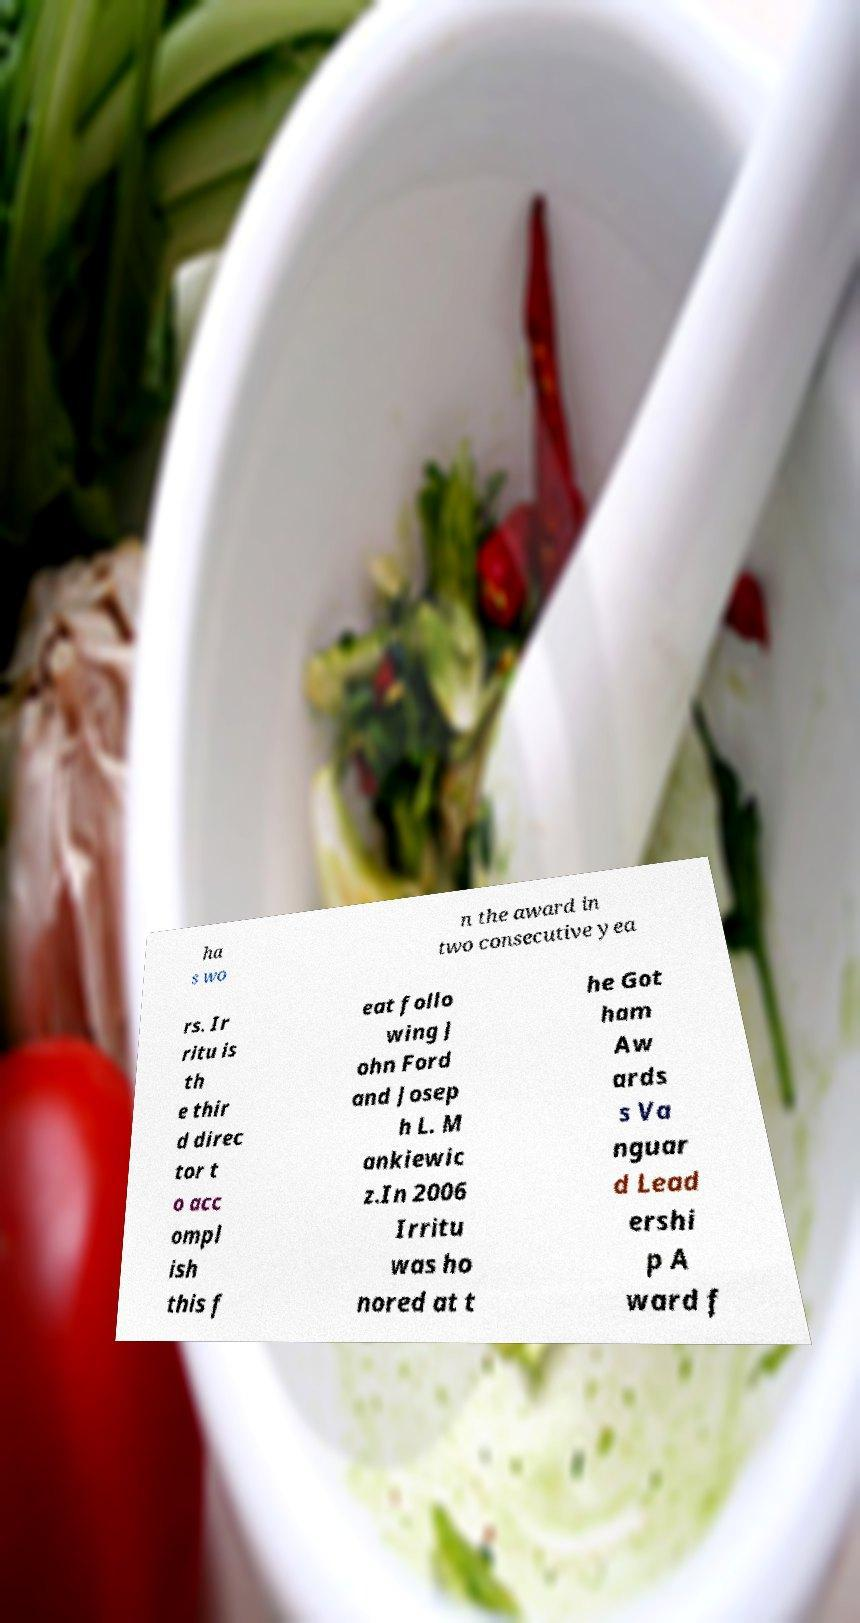I need the written content from this picture converted into text. Can you do that? ha s wo n the award in two consecutive yea rs. Ir ritu is th e thir d direc tor t o acc ompl ish this f eat follo wing J ohn Ford and Josep h L. M ankiewic z.In 2006 Irritu was ho nored at t he Got ham Aw ards s Va nguar d Lead ershi p A ward f 